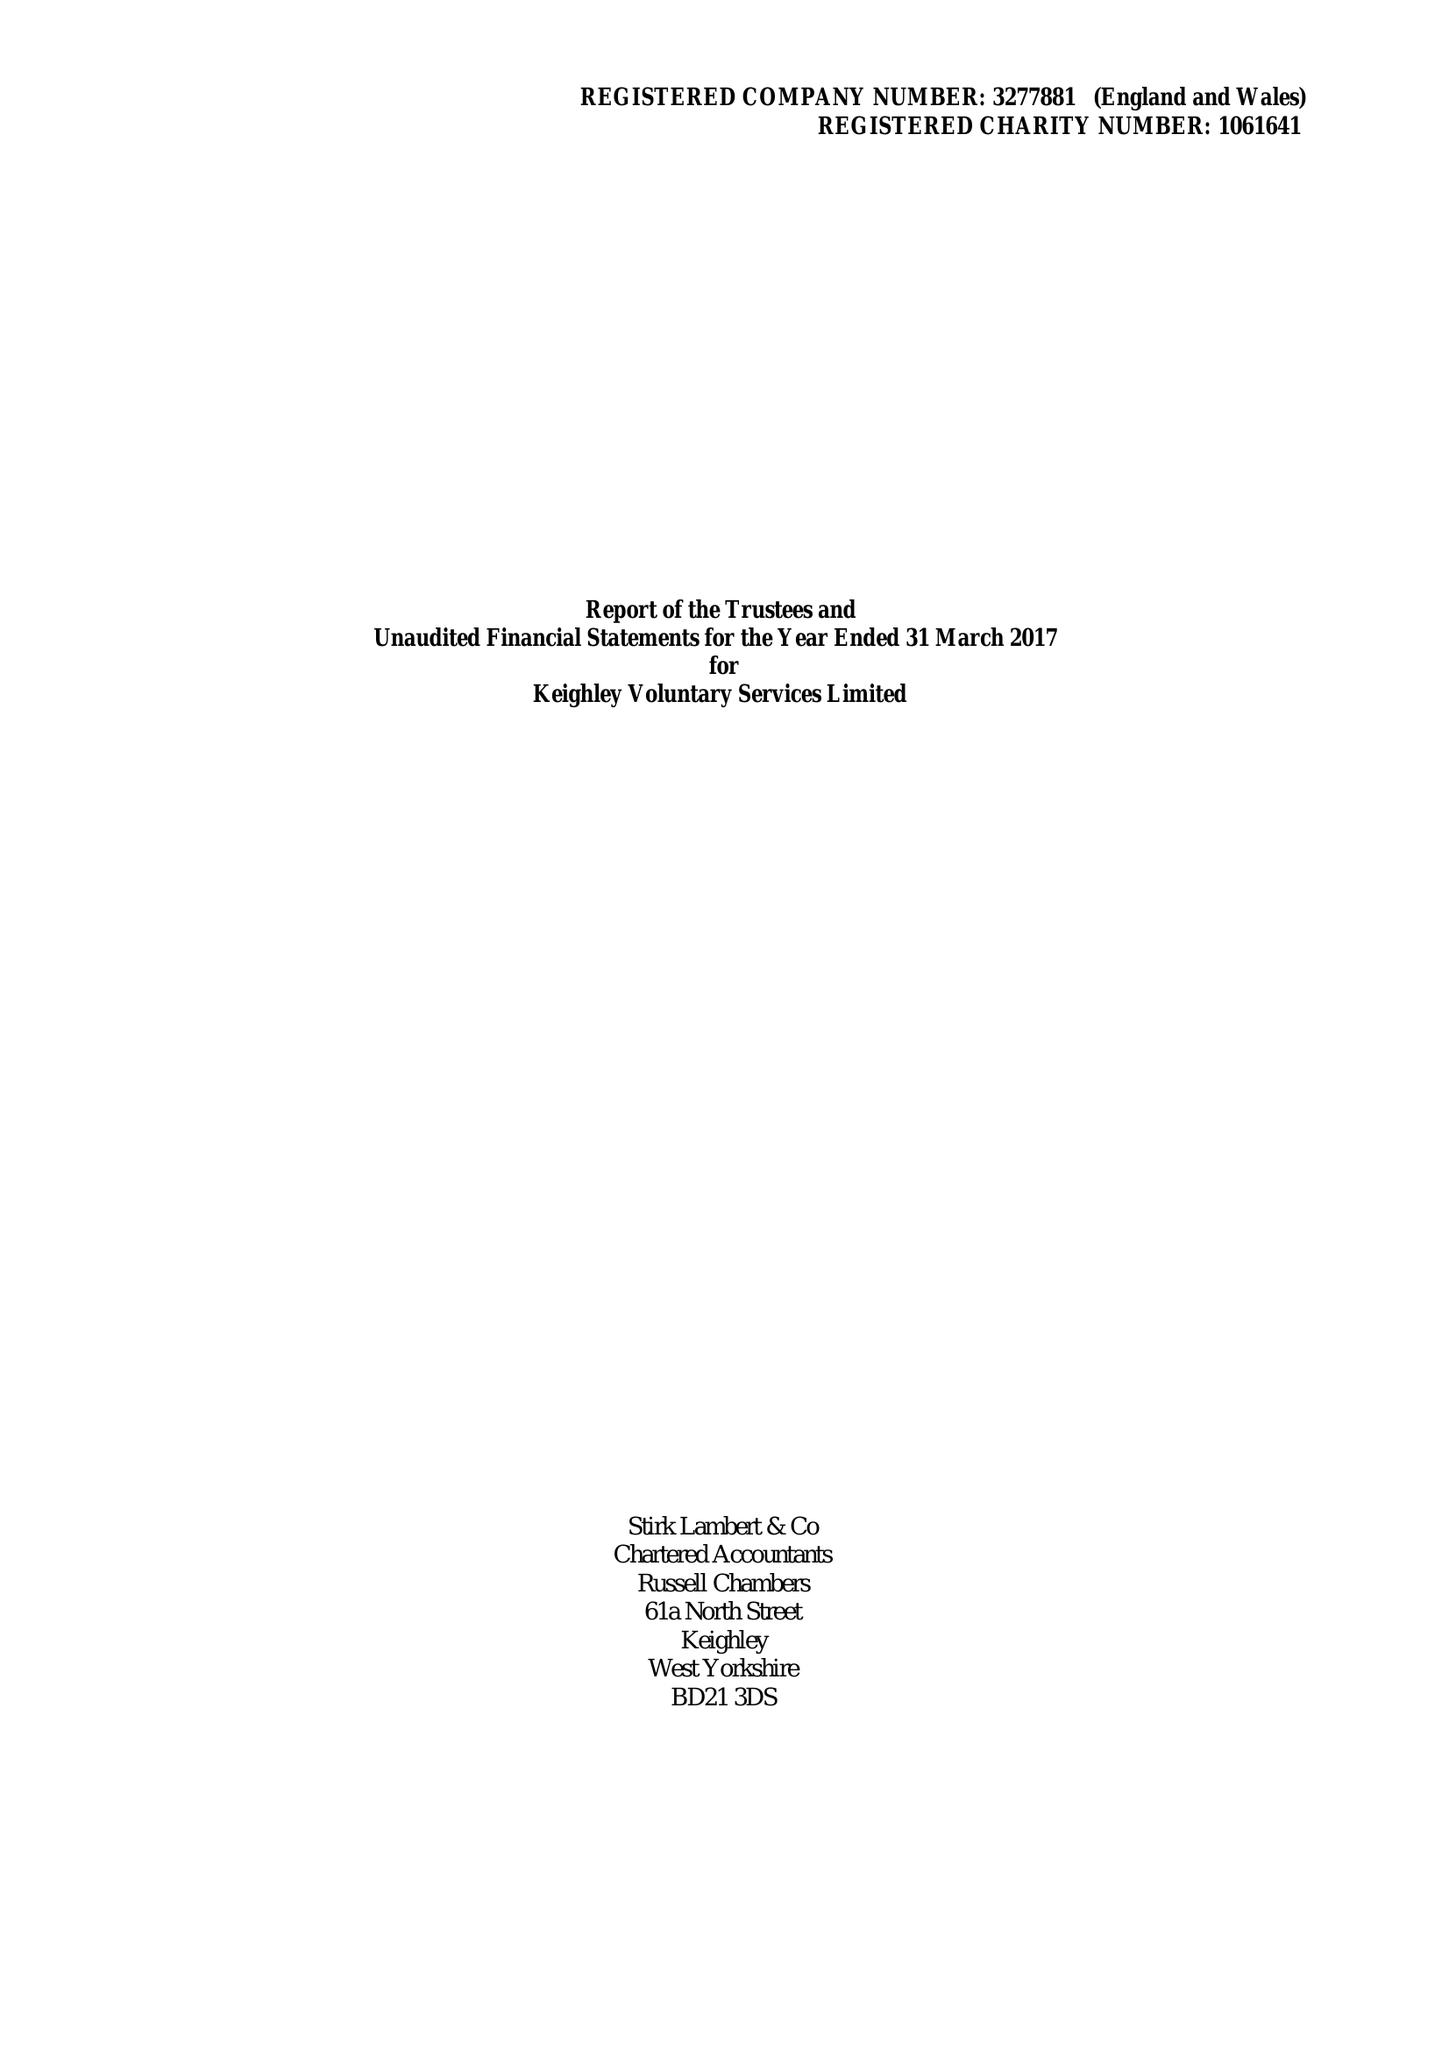What is the value for the address__postcode?
Answer the question using a single word or phrase. BD21 3JD 